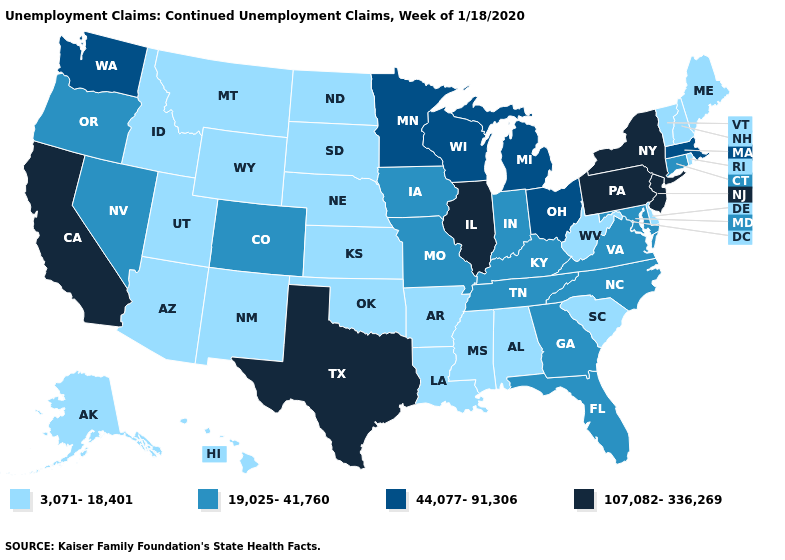Which states have the highest value in the USA?
Short answer required. California, Illinois, New Jersey, New York, Pennsylvania, Texas. Name the states that have a value in the range 44,077-91,306?
Answer briefly. Massachusetts, Michigan, Minnesota, Ohio, Washington, Wisconsin. Among the states that border Nevada , which have the highest value?
Short answer required. California. What is the value of Iowa?
Short answer required. 19,025-41,760. What is the value of California?
Keep it brief. 107,082-336,269. What is the value of Rhode Island?
Answer briefly. 3,071-18,401. Among the states that border Vermont , does New Hampshire have the lowest value?
Keep it brief. Yes. What is the value of Michigan?
Answer briefly. 44,077-91,306. Among the states that border Utah , which have the highest value?
Answer briefly. Colorado, Nevada. Which states hav the highest value in the South?
Write a very short answer. Texas. Name the states that have a value in the range 19,025-41,760?
Write a very short answer. Colorado, Connecticut, Florida, Georgia, Indiana, Iowa, Kentucky, Maryland, Missouri, Nevada, North Carolina, Oregon, Tennessee, Virginia. What is the value of Georgia?
Concise answer only. 19,025-41,760. Name the states that have a value in the range 44,077-91,306?
Write a very short answer. Massachusetts, Michigan, Minnesota, Ohio, Washington, Wisconsin. What is the highest value in states that border Idaho?
Give a very brief answer. 44,077-91,306. Which states have the highest value in the USA?
Concise answer only. California, Illinois, New Jersey, New York, Pennsylvania, Texas. 